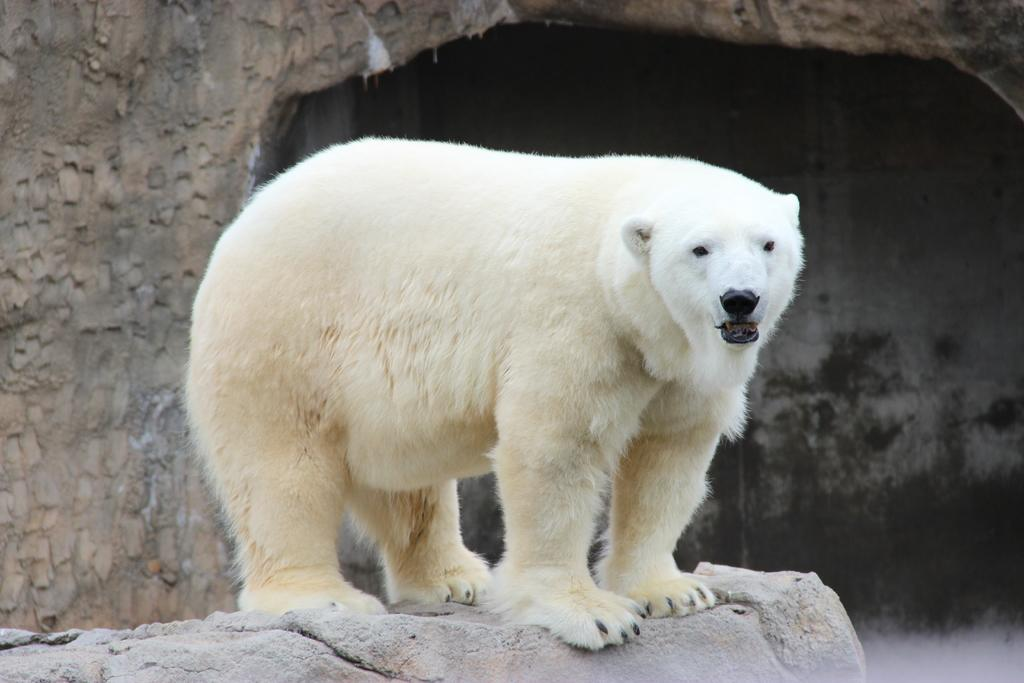What type of animal is in the image? The type of animal cannot be determined from the provided facts. What is the background of the image? There is a wall in the image. What other object is present in the image? There is a rock in the image. What grade is the animal in the image currently attending? There is no indication in the image that the animal is attending any grade, as animals do not attend school. 